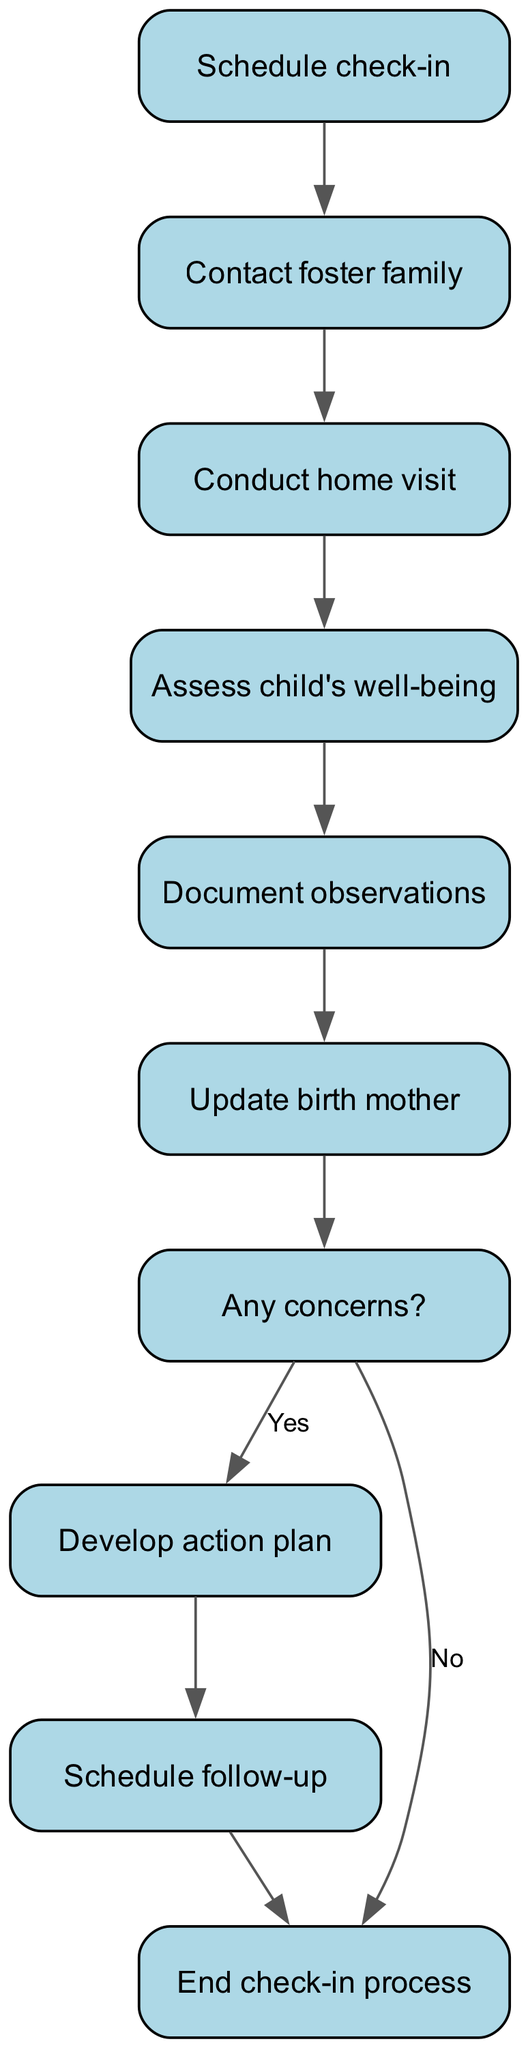What is the first step in the process? The diagram starts with the node labeled "Schedule check-in," which indicates that the first action in the protocol is to schedule a check-in.
Answer: Schedule check-in How many nodes are in the diagram? By counting each unique step in the protocol, we see there are ten nodes included in the diagram that represent various stages of the child welfare check-in process.
Answer: 10 What happens after contacting the foster family? The flowchart indicates that after the "Contact foster family" step, the next action is "Conduct home visit," which is a sequential step in the protocol.
Answer: Conduct home visit Is there a step for updating the birth mother? Yes, there is a step labeled "Update birth mother" in the diagram, showing that communication with the birth mother is part of the process.
Answer: Yes What happens if there are concerns regarding the child's well-being? According to the diagram, if there are concerns, the flow leads to the "Develop action plan" step, indicating that actions will be taken based on the concerns raised.
Answer: Develop action plan What is the final step in the check-in process? The diagram concludes with the node labeled "End check-in process," indicating that once all actions are completed, the protocol reaches its conclusion.
Answer: End check-in process How many connections are labeled "Yes" in the diagram? There is only one labeled connection for "Yes," which occurs when the flow goes from "Any concerns?" to "Develop action plan," indicating a decision point in the process.
Answer: 1 What step follows scheduling a follow-up? In the flowchart, after "Schedule follow-up," the process leads directly to the "End check-in process," which indicates the conclusion of the check-in procedure.
Answer: End check-in process What is the significance of the "Any concerns?" step? The "Any concerns?" step acts as a decision point where outcomes diverge based on whether concerns are identified, leading to either developing an action plan or concluding the process.
Answer: Decision point 